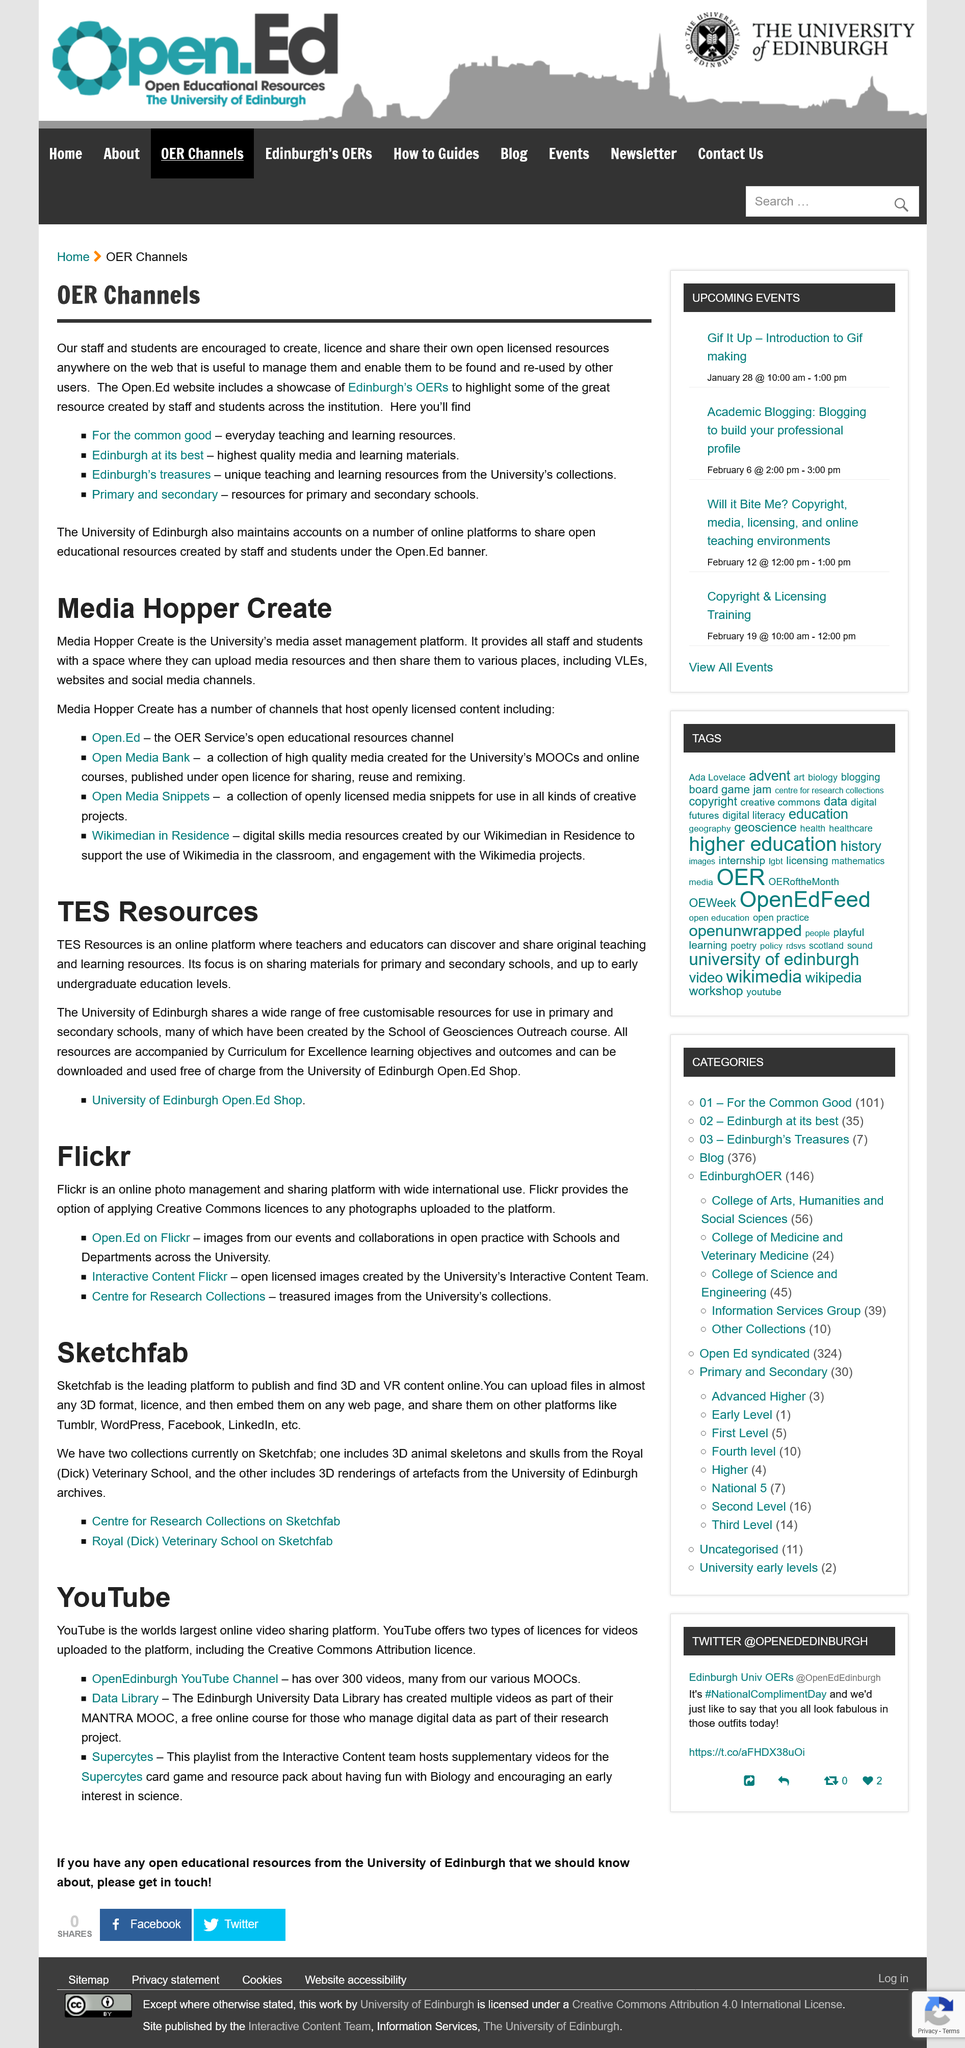Give some essential details in this illustration. Flick provides the option for users to apply Creative Commons licenses to photographs uploaded to the platform. The Open.Ed website provides resources for primary and secondary schools. Sketchfab is the leading platform for publishing and discovering 3D and VR content online. Media Hopper Create is the University's media asset management platform, a tool designed to facilitate the organization and management of media assets, such as images, videos, and audio files, in a centralized and efficient manner. Flickr is an online photo management platform that belongs to an entity. 